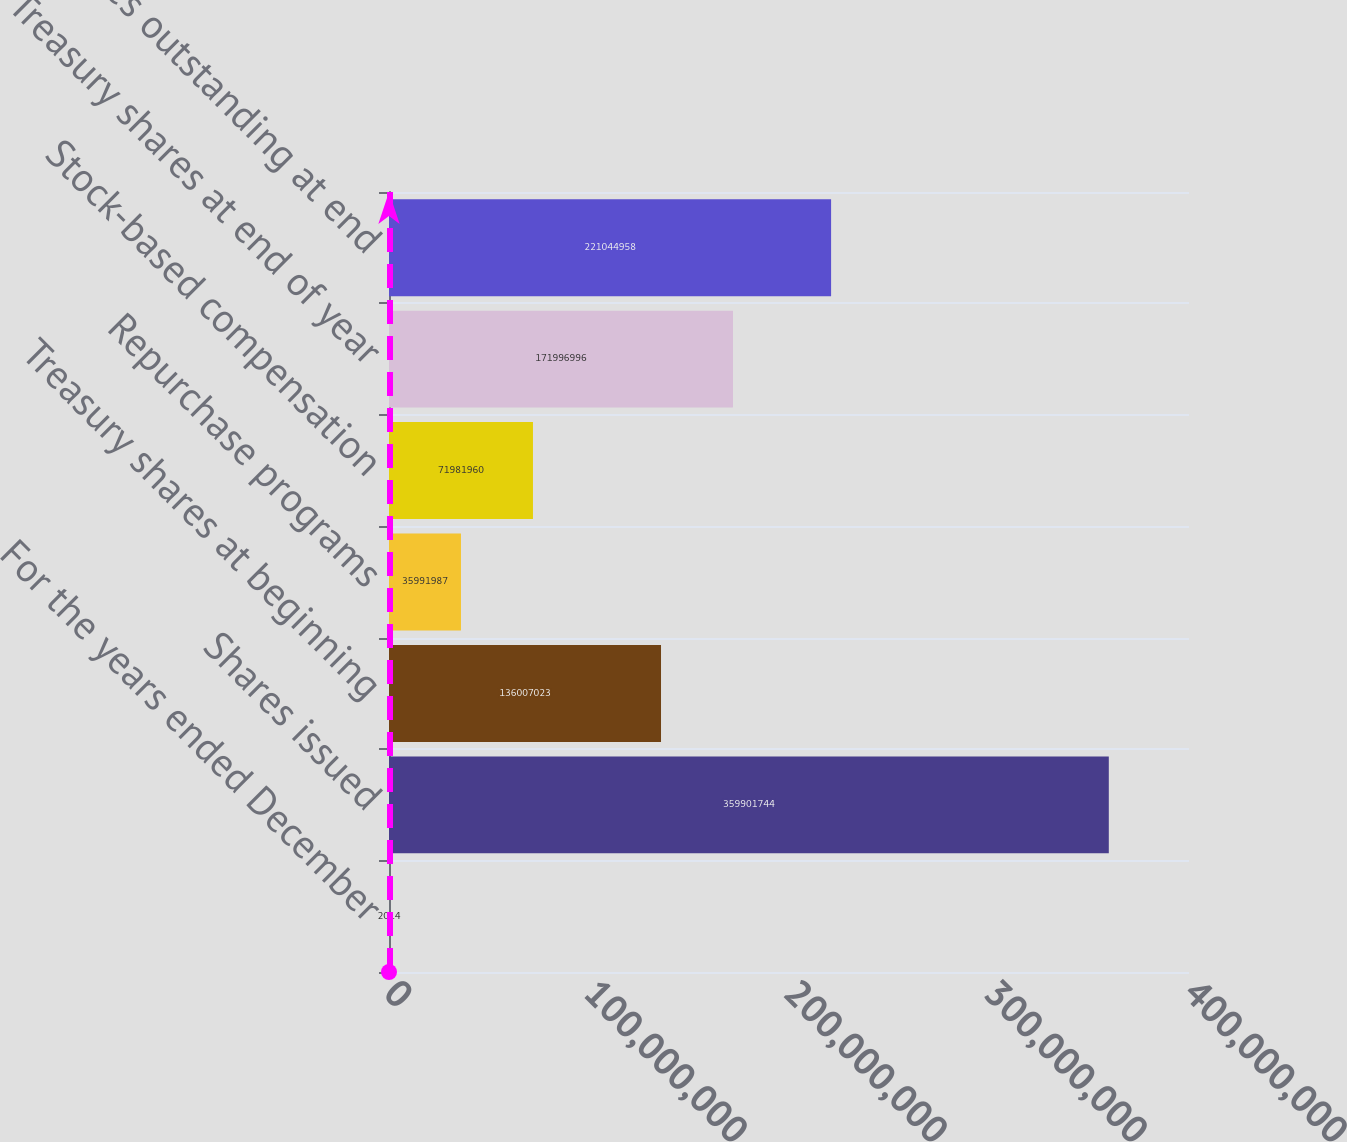<chart> <loc_0><loc_0><loc_500><loc_500><bar_chart><fcel>For the years ended December<fcel>Shares issued<fcel>Treasury shares at beginning<fcel>Repurchase programs<fcel>Stock-based compensation<fcel>Treasury shares at end of year<fcel>Net shares outstanding at end<nl><fcel>2014<fcel>3.59902e+08<fcel>1.36007e+08<fcel>3.5992e+07<fcel>7.1982e+07<fcel>1.71997e+08<fcel>2.21045e+08<nl></chart> 